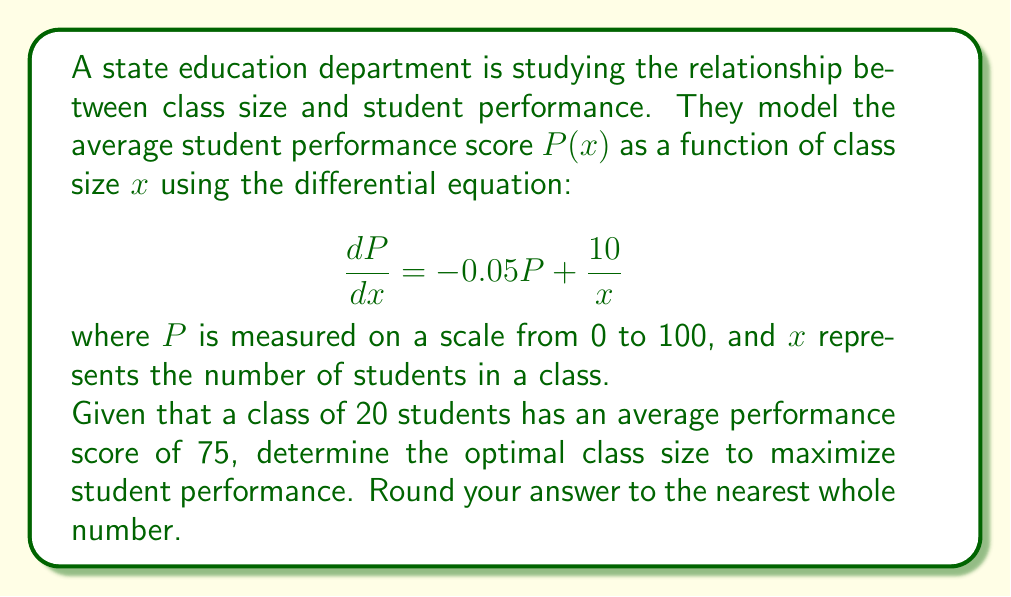Can you solve this math problem? To solve this problem, we'll follow these steps:

1) First, we need to solve the differential equation. This is a first-order linear differential equation.

2) The general solution to this equation is:
   $$P(x) = Ce^{-0.05x} + 200$$
   where $C$ is a constant of integration.

3) We can find $C$ using the given condition: when $x = 20$, $P = 75$. Substituting these values:
   $$75 = Ce^{-0.05(20)} + 200$$
   $$C = (75 - 200)e^{1} = -125e \approx -339.79$$

4) Now we have the specific solution:
   $$P(x) = 200 - 339.79e^{-0.05x}$$

5) To find the maximum, we differentiate $P(x)$ and set it to zero:
   $$\frac{dP}{dx} = 339.79 \cdot 0.05e^{-0.05x} = 0$$

6) This equation is only satisfied when $x$ approaches infinity, which isn't practical. Instead, we should look for the point where $\frac{dP}{dx} = 0$ in our original differential equation:

   $$-0.05P + \frac{10}{x} = 0$$

7) Substituting our solution for $P(x)$:
   $$-0.05(200 - 339.79e^{-0.05x}) + \frac{10}{x} = 0$$

8) This equation can be solved numerically. Using a numerical method or graphing calculator, we find that $x \approx 20.41$.

9) Rounding to the nearest whole number, we get 20.

Therefore, the optimal class size to maximize student performance is approximately 20 students.
Answer: 20 students 